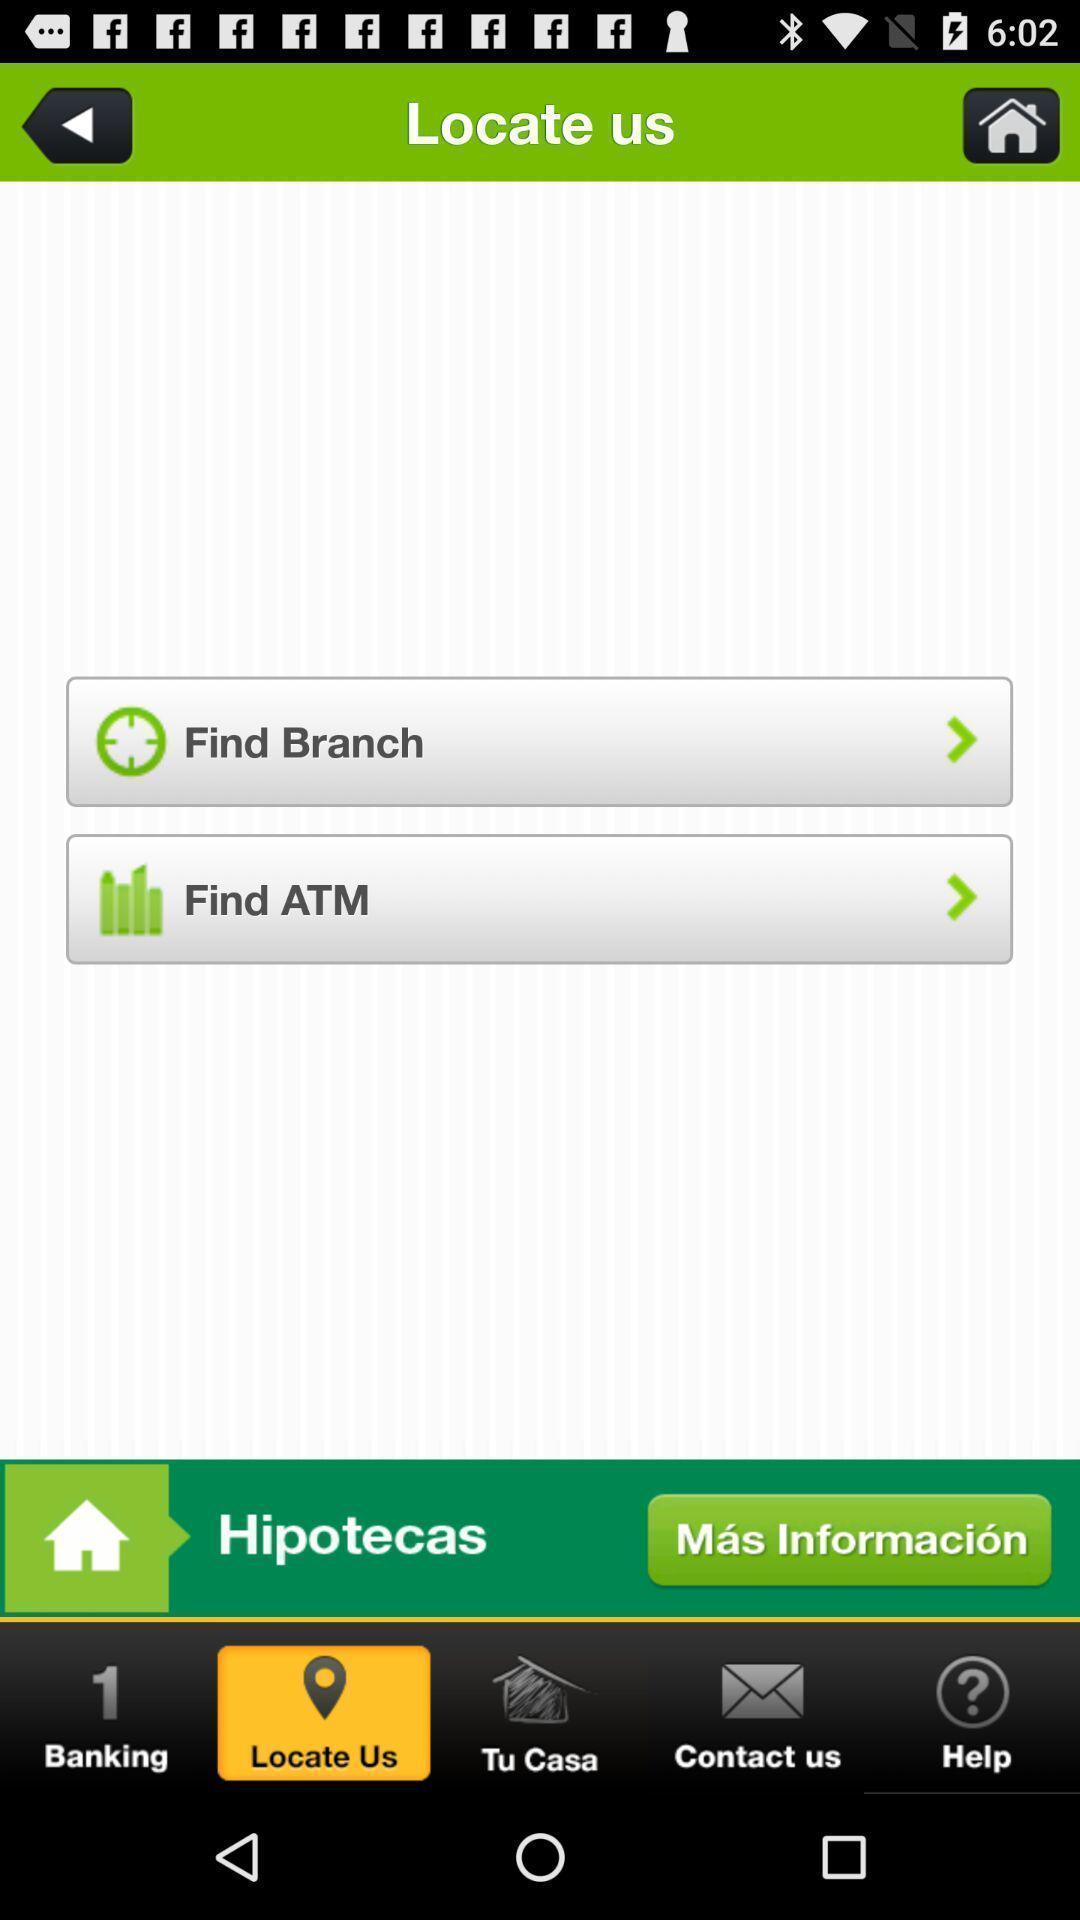What can you discern from this picture? Screen showing finding page of a backing app. 